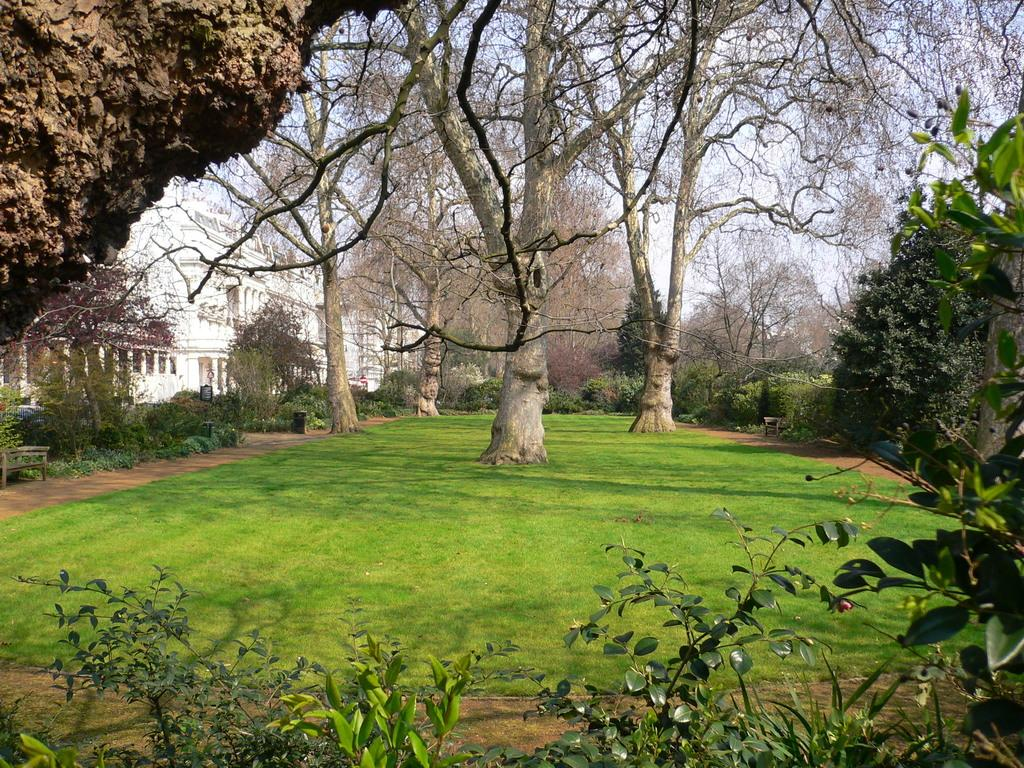What types of vegetation can be seen in the foreground of the image? There are plants and grass land in the foreground of the image. What other objects are present in the foreground of the image? There is a trunk and trees in the foreground of the image. Can you describe the background of the image? There are trees and a building in the background of the image, along with sky visible. What type of insect can be seen causing damage to the plate in the image? There is no insect or plate present in the image. What is the cause of the damage to the plate in the image? There is no plate or damage present in the image. 